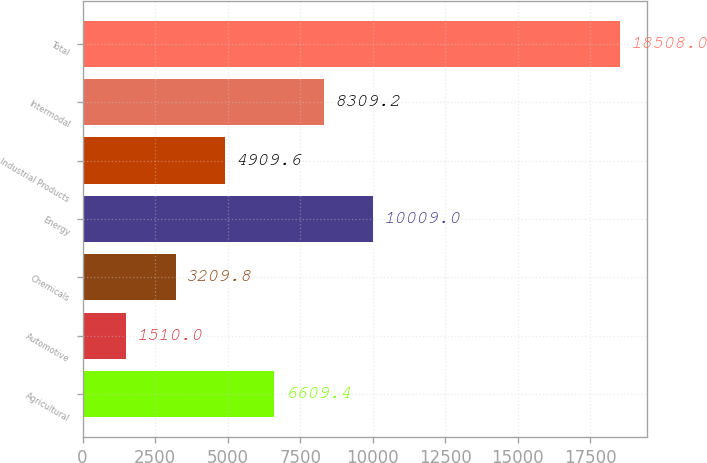<chart> <loc_0><loc_0><loc_500><loc_500><bar_chart><fcel>Agricultural<fcel>Automotive<fcel>Chemicals<fcel>Energy<fcel>Industrial Products<fcel>Intermodal<fcel>Total<nl><fcel>6609.4<fcel>1510<fcel>3209.8<fcel>10009<fcel>4909.6<fcel>8309.2<fcel>18508<nl></chart> 